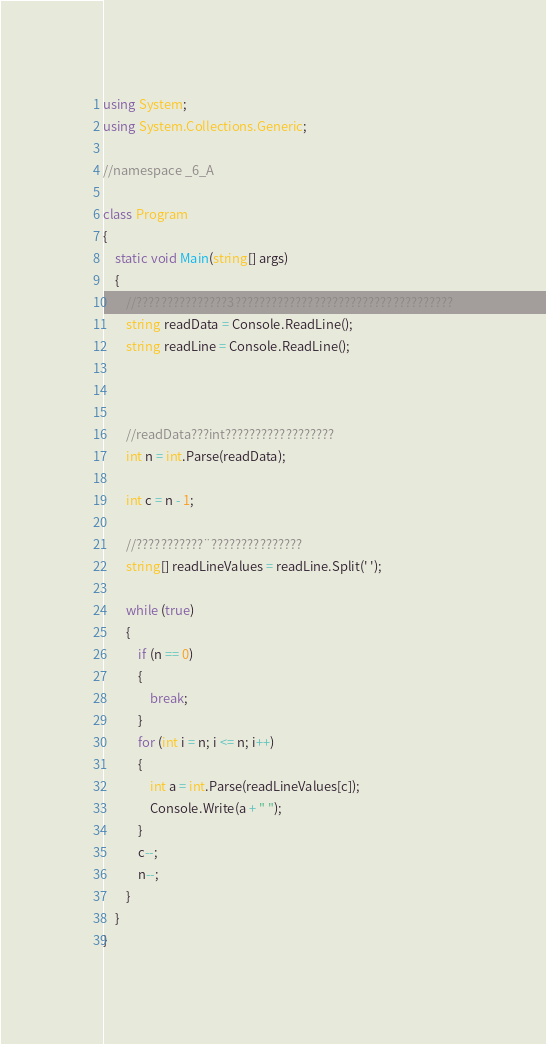Convert code to text. <code><loc_0><loc_0><loc_500><loc_500><_C#_>using System;
using System.Collections.Generic;

//namespace _6_A

class Program
{
    static void Main(string[] args)
    {
        //???????????????3????????????????????????????????????
        string readData = Console.ReadLine();
        string readLine = Console.ReadLine();



        //readData???int??????????????????
        int n = int.Parse(readData);

        int c = n - 1;

        //???????????¨???????????????
        string[] readLineValues = readLine.Split(' ');

        while (true)
        {
            if (n == 0)
            {
                break;
            }
            for (int i = n; i <= n; i++)
            {
                int a = int.Parse(readLineValues[c]);
                Console.Write(a + " ");
            }
            c--;
            n--;
        }
    }
}</code> 